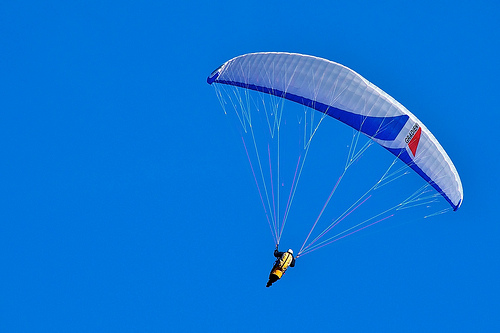What does the person hold onto? The person is holding onto a cord, which is attached to the parachute, helping them control their descent. 